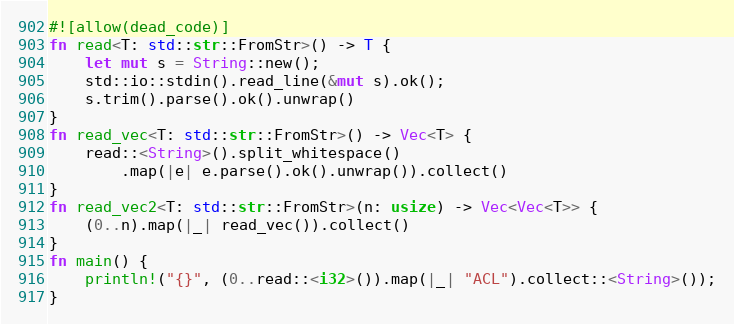Convert code to text. <code><loc_0><loc_0><loc_500><loc_500><_Rust_>#![allow(dead_code)]
fn read<T: std::str::FromStr>() -> T {
    let mut s = String::new();
    std::io::stdin().read_line(&mut s).ok();
    s.trim().parse().ok().unwrap()
}
fn read_vec<T: std::str::FromStr>() -> Vec<T> {
    read::<String>().split_whitespace()
        .map(|e| e.parse().ok().unwrap()).collect()
}
fn read_vec2<T: std::str::FromStr>(n: usize) -> Vec<Vec<T>> {
    (0..n).map(|_| read_vec()).collect()
}
fn main() {
    println!("{}", (0..read::<i32>()).map(|_| "ACL").collect::<String>());
}</code> 